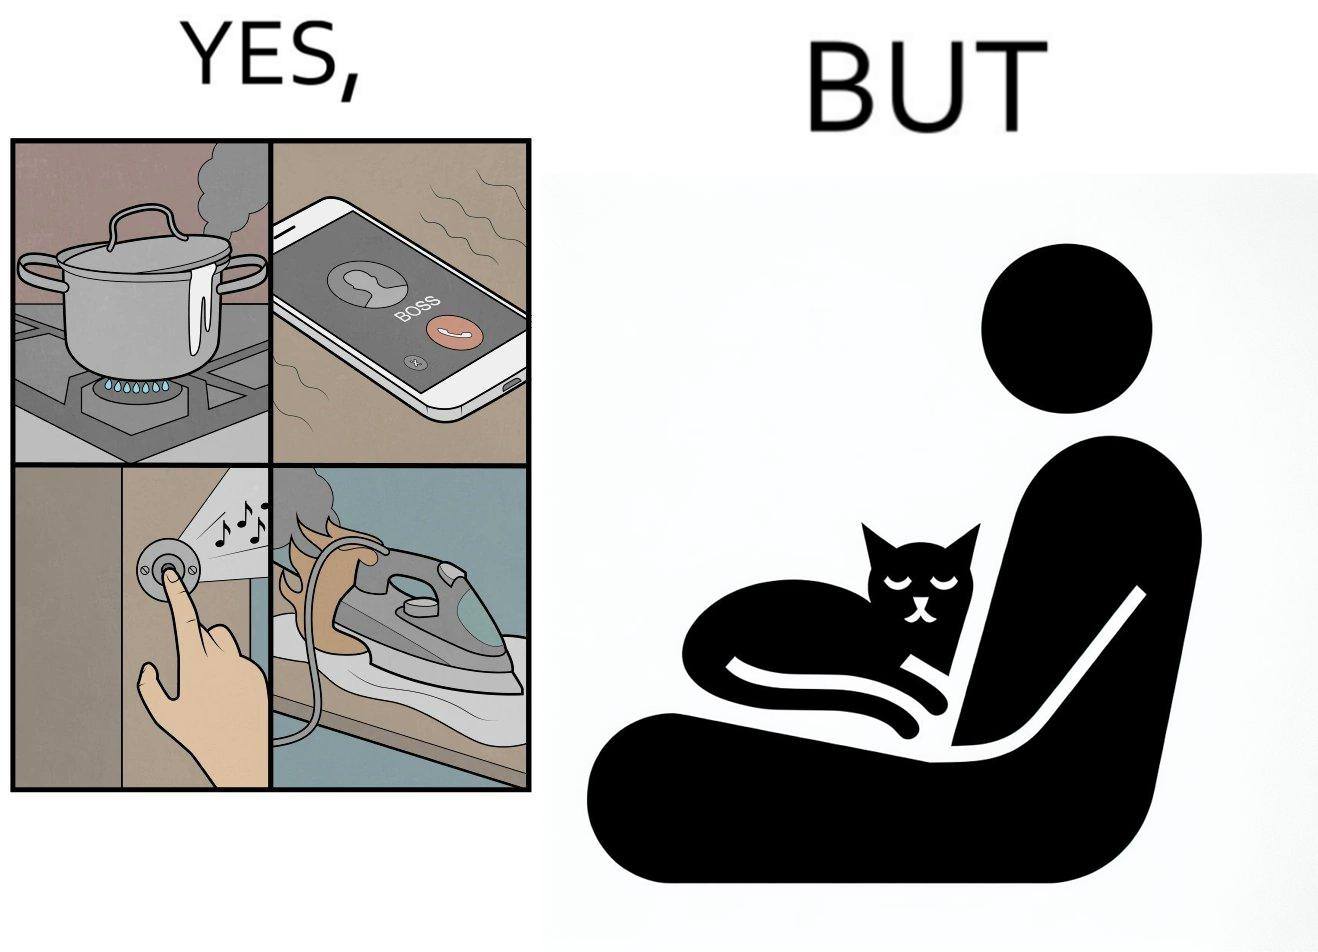What is shown in this image? the irony in this image is that people ignore all the chaos around them and get distracted by a cat. 